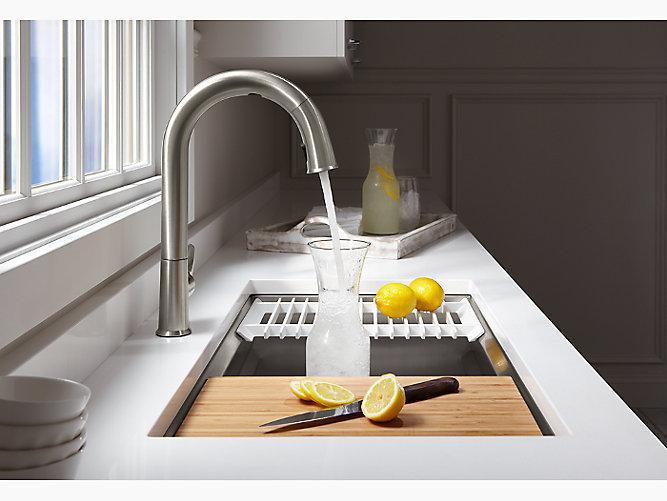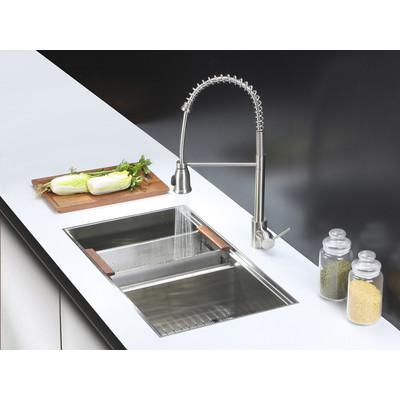The first image is the image on the left, the second image is the image on the right. For the images displayed, is the sentence "A bottle is being filled with water from a faucet in the left image." factually correct? Answer yes or no. Yes. The first image is the image on the left, the second image is the image on the right. Given the left and right images, does the statement "A lemon sits on a white rack near the sink in one of the images." hold true? Answer yes or no. Yes. 